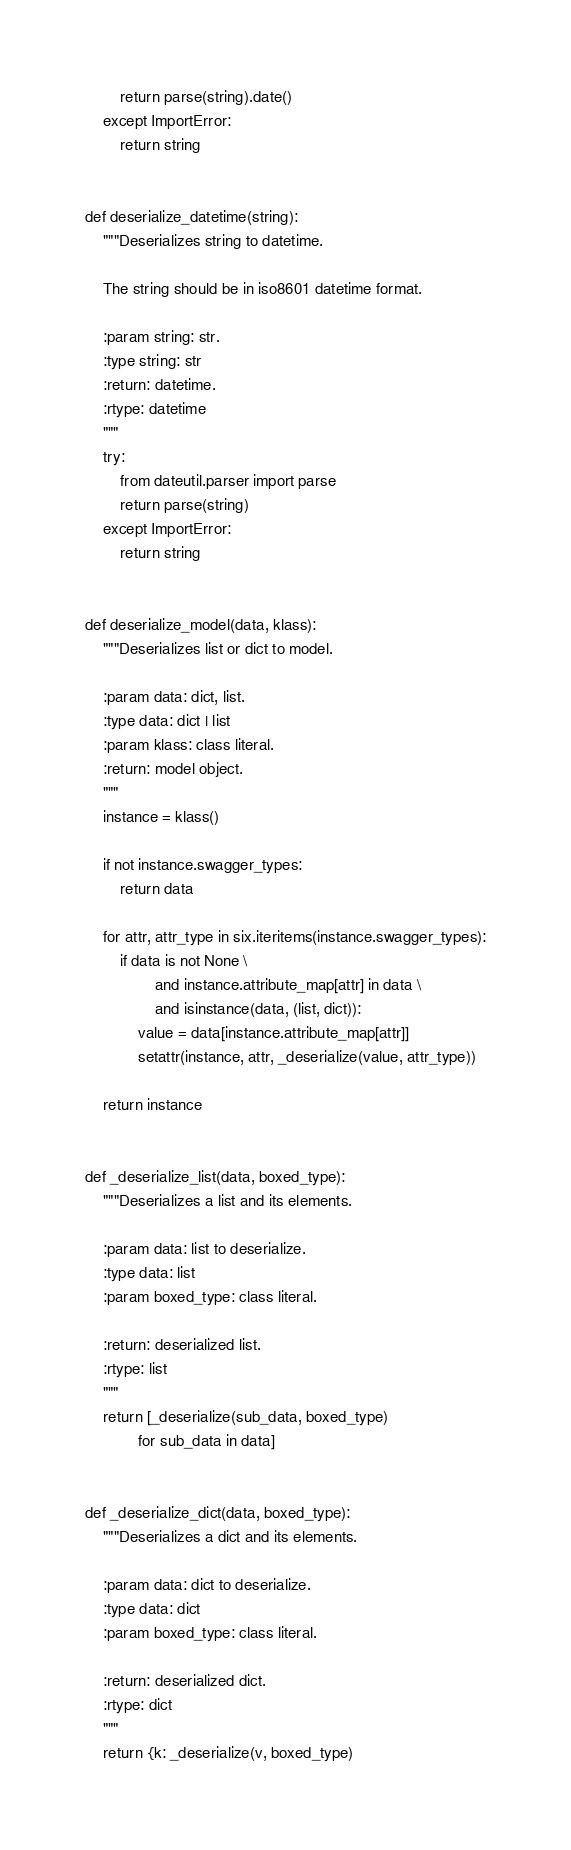Convert code to text. <code><loc_0><loc_0><loc_500><loc_500><_Python_>        return parse(string).date()
    except ImportError:
        return string


def deserialize_datetime(string):
    """Deserializes string to datetime.

    The string should be in iso8601 datetime format.

    :param string: str.
    :type string: str
    :return: datetime.
    :rtype: datetime
    """
    try:
        from dateutil.parser import parse
        return parse(string)
    except ImportError:
        return string


def deserialize_model(data, klass):
    """Deserializes list or dict to model.

    :param data: dict, list.
    :type data: dict | list
    :param klass: class literal.
    :return: model object.
    """
    instance = klass()

    if not instance.swagger_types:
        return data

    for attr, attr_type in six.iteritems(instance.swagger_types):
        if data is not None \
                and instance.attribute_map[attr] in data \
                and isinstance(data, (list, dict)):
            value = data[instance.attribute_map[attr]]
            setattr(instance, attr, _deserialize(value, attr_type))

    return instance


def _deserialize_list(data, boxed_type):
    """Deserializes a list and its elements.

    :param data: list to deserialize.
    :type data: list
    :param boxed_type: class literal.

    :return: deserialized list.
    :rtype: list
    """
    return [_deserialize(sub_data, boxed_type)
            for sub_data in data]


def _deserialize_dict(data, boxed_type):
    """Deserializes a dict and its elements.

    :param data: dict to deserialize.
    :type data: dict
    :param boxed_type: class literal.

    :return: deserialized dict.
    :rtype: dict
    """
    return {k: _deserialize(v, boxed_type)</code> 